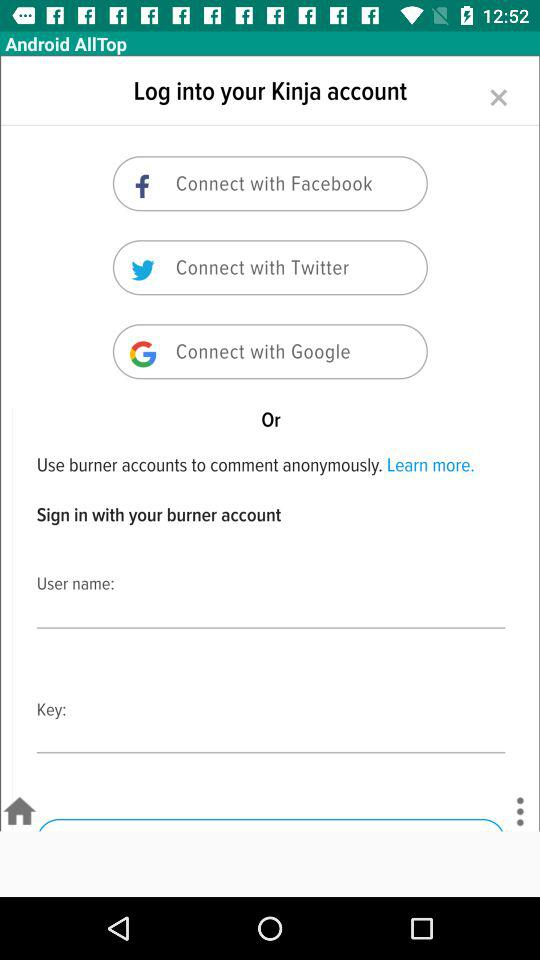How many text inputs are there for logging in?
Answer the question using a single word or phrase. 2 